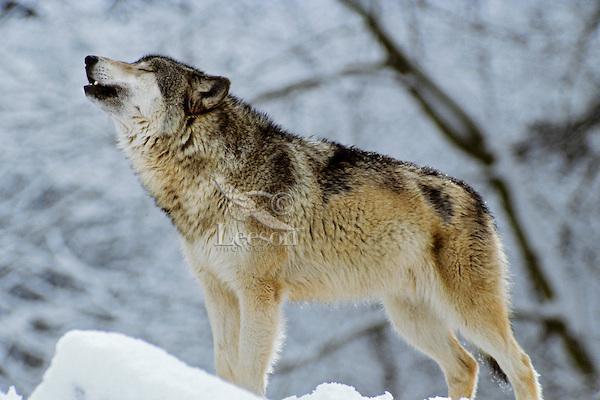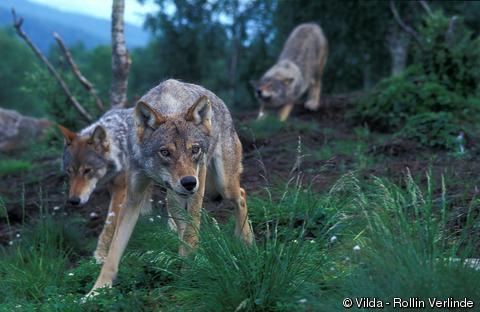The first image is the image on the left, the second image is the image on the right. For the images displayed, is the sentence "There is one wolf per image, and none of the wolves are showing their teeth." factually correct? Answer yes or no. No. 